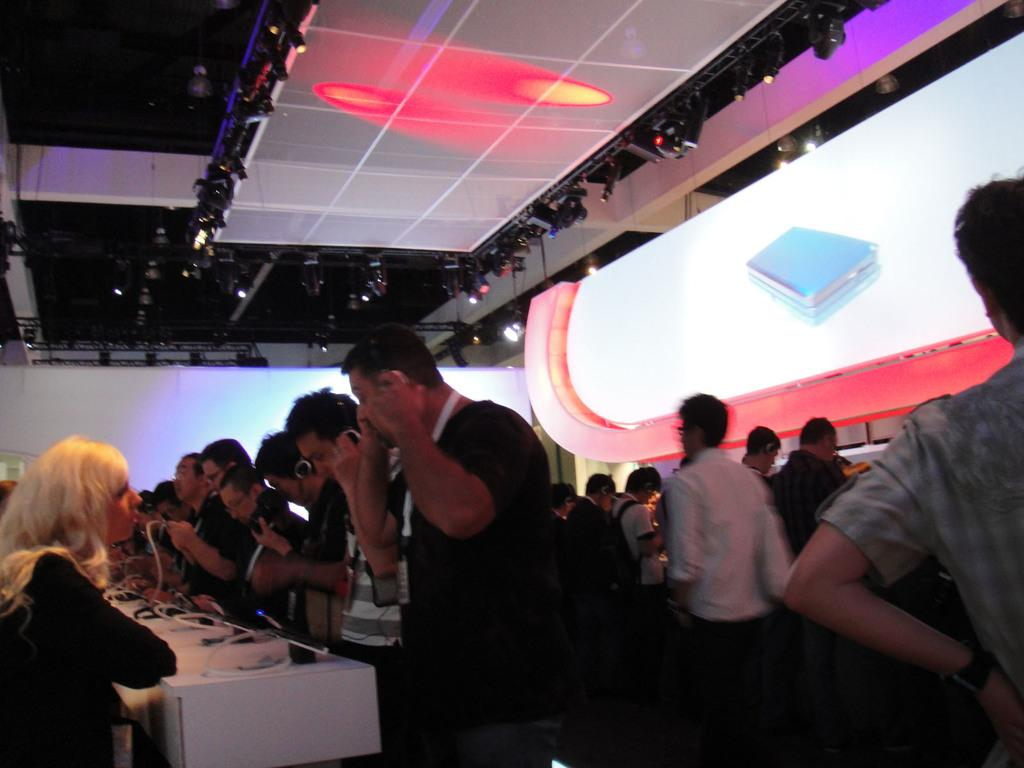What is happening in the room in the image? There are people standing in a room. What piece of furniture is present in the room? There is a table in the room. What can be seen on the table? There are objects on the table. What type of wool is being used by the laborer in the image? There is no laborer or wool present in the image. What is the purpose of the meeting taking place in the image? There is no meeting present in the image; it simply shows people standing in a room with a table and objects on it. 